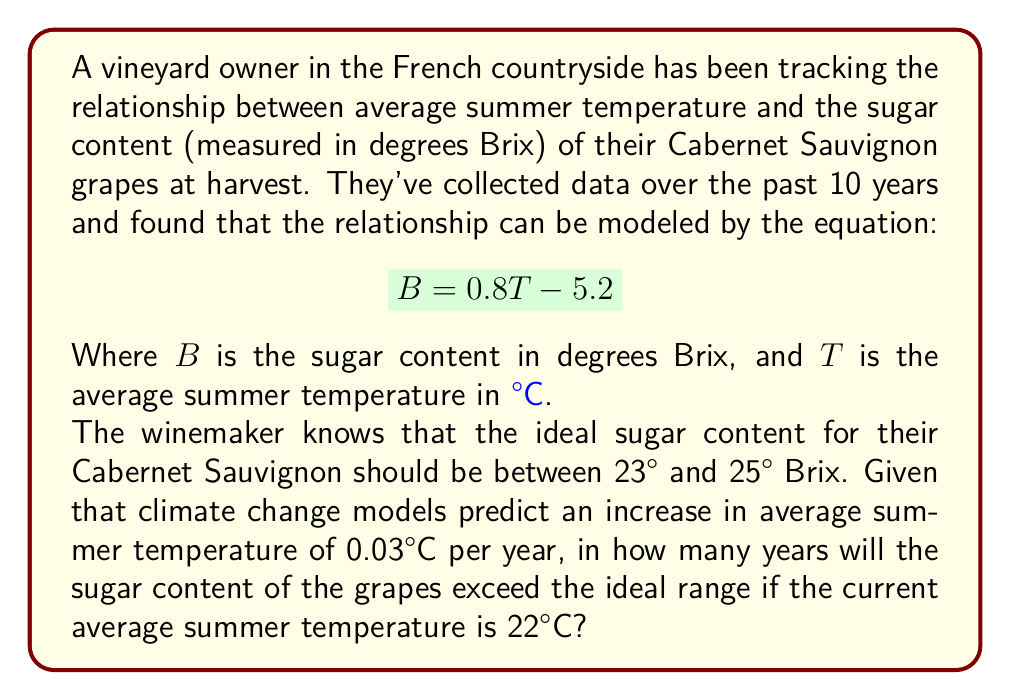Solve this math problem. Let's approach this problem step-by-step:

1) First, we need to find the temperature range that corresponds to the ideal sugar content range:

   For 23° Brix: $23 = 0.8T - 5.2$
   $28.2 = 0.8T$
   $T = 35.25°C$

   For 25° Brix: $25 = 0.8T - 5.2$
   $30.2 = 0.8T$
   $T = 37.75°C$

2) The upper limit of the ideal range is 37.75°C. We need to find out how long it will take for the temperature to reach this value.

3) The current temperature is 22°C, and it's increasing by 0.03°C per year.

4) Let $x$ be the number of years. We can set up the equation:

   $22 + 0.03x = 37.75$

5) Solving for $x$:

   $0.03x = 15.75$
   $x = 15.75 / 0.03 = 525$ years

6) However, the question asks when it will exceed the ideal range, so we need the next whole number of years after 525.
Answer: 526 years 